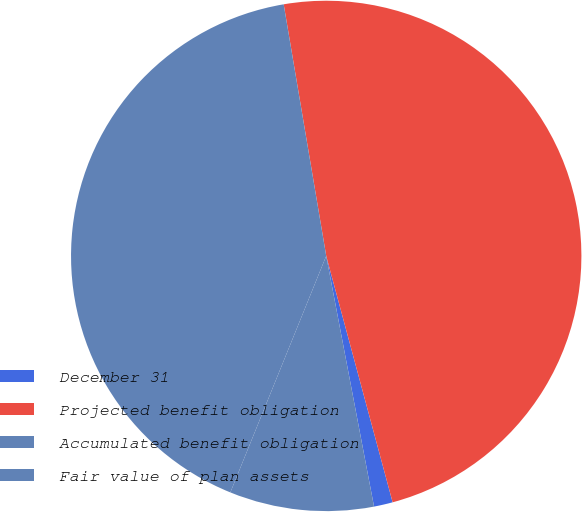Convert chart. <chart><loc_0><loc_0><loc_500><loc_500><pie_chart><fcel>December 31<fcel>Projected benefit obligation<fcel>Accumulated benefit obligation<fcel>Fair value of plan assets<nl><fcel>1.19%<fcel>48.47%<fcel>41.2%<fcel>9.13%<nl></chart> 